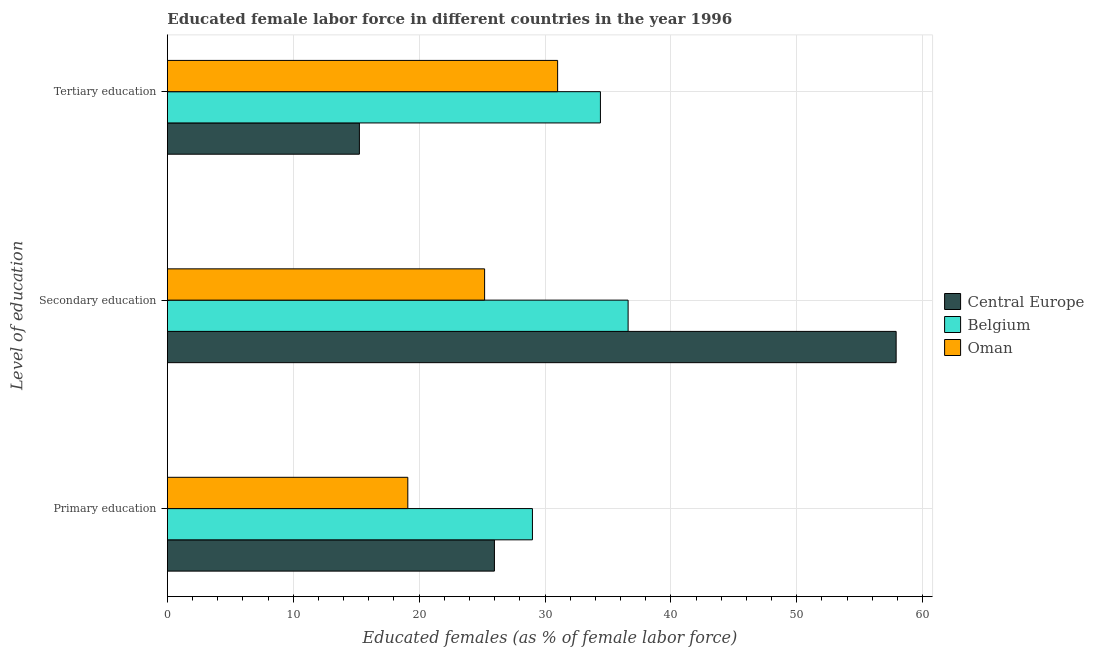How many different coloured bars are there?
Offer a terse response. 3. How many bars are there on the 2nd tick from the bottom?
Your answer should be very brief. 3. What is the label of the 1st group of bars from the top?
Keep it short and to the point. Tertiary education. What is the percentage of female labor force who received tertiary education in Belgium?
Make the answer very short. 34.4. Across all countries, what is the maximum percentage of female labor force who received tertiary education?
Your answer should be very brief. 34.4. Across all countries, what is the minimum percentage of female labor force who received primary education?
Offer a terse response. 19.1. In which country was the percentage of female labor force who received tertiary education minimum?
Your answer should be compact. Central Europe. What is the total percentage of female labor force who received tertiary education in the graph?
Your answer should be very brief. 80.65. What is the difference between the percentage of female labor force who received primary education in Oman and that in Belgium?
Give a very brief answer. -9.9. What is the difference between the percentage of female labor force who received primary education in Central Europe and the percentage of female labor force who received tertiary education in Belgium?
Offer a very short reply. -8.42. What is the average percentage of female labor force who received secondary education per country?
Provide a succinct answer. 39.9. What is the difference between the percentage of female labor force who received tertiary education and percentage of female labor force who received secondary education in Central Europe?
Provide a short and direct response. -42.64. In how many countries, is the percentage of female labor force who received secondary education greater than 52 %?
Your answer should be compact. 1. What is the ratio of the percentage of female labor force who received primary education in Oman to that in Belgium?
Provide a succinct answer. 0.66. Is the percentage of female labor force who received secondary education in Oman less than that in Central Europe?
Give a very brief answer. Yes. Is the difference between the percentage of female labor force who received primary education in Belgium and Central Europe greater than the difference between the percentage of female labor force who received secondary education in Belgium and Central Europe?
Provide a short and direct response. Yes. What is the difference between the highest and the second highest percentage of female labor force who received secondary education?
Make the answer very short. 21.29. What is the difference between the highest and the lowest percentage of female labor force who received tertiary education?
Provide a short and direct response. 19.15. In how many countries, is the percentage of female labor force who received primary education greater than the average percentage of female labor force who received primary education taken over all countries?
Give a very brief answer. 2. What does the 2nd bar from the top in Primary education represents?
Provide a succinct answer. Belgium. What does the 3rd bar from the bottom in Tertiary education represents?
Keep it short and to the point. Oman. How many bars are there?
Give a very brief answer. 9. What is the difference between two consecutive major ticks on the X-axis?
Give a very brief answer. 10. Does the graph contain any zero values?
Provide a succinct answer. No. Does the graph contain grids?
Offer a very short reply. Yes. Where does the legend appear in the graph?
Offer a terse response. Center right. How are the legend labels stacked?
Provide a succinct answer. Vertical. What is the title of the graph?
Provide a short and direct response. Educated female labor force in different countries in the year 1996. What is the label or title of the X-axis?
Offer a terse response. Educated females (as % of female labor force). What is the label or title of the Y-axis?
Offer a very short reply. Level of education. What is the Educated females (as % of female labor force) of Central Europe in Primary education?
Offer a very short reply. 25.98. What is the Educated females (as % of female labor force) of Oman in Primary education?
Your response must be concise. 19.1. What is the Educated females (as % of female labor force) of Central Europe in Secondary education?
Your response must be concise. 57.89. What is the Educated females (as % of female labor force) of Belgium in Secondary education?
Your answer should be very brief. 36.6. What is the Educated females (as % of female labor force) in Oman in Secondary education?
Offer a very short reply. 25.2. What is the Educated females (as % of female labor force) in Central Europe in Tertiary education?
Give a very brief answer. 15.25. What is the Educated females (as % of female labor force) in Belgium in Tertiary education?
Provide a succinct answer. 34.4. What is the Educated females (as % of female labor force) in Oman in Tertiary education?
Offer a very short reply. 31. Across all Level of education, what is the maximum Educated females (as % of female labor force) of Central Europe?
Offer a very short reply. 57.89. Across all Level of education, what is the maximum Educated females (as % of female labor force) in Belgium?
Provide a short and direct response. 36.6. Across all Level of education, what is the maximum Educated females (as % of female labor force) in Oman?
Your answer should be very brief. 31. Across all Level of education, what is the minimum Educated females (as % of female labor force) of Central Europe?
Offer a terse response. 15.25. Across all Level of education, what is the minimum Educated females (as % of female labor force) of Belgium?
Provide a short and direct response. 29. Across all Level of education, what is the minimum Educated females (as % of female labor force) of Oman?
Make the answer very short. 19.1. What is the total Educated females (as % of female labor force) in Central Europe in the graph?
Provide a succinct answer. 99.13. What is the total Educated females (as % of female labor force) of Belgium in the graph?
Provide a succinct answer. 100. What is the total Educated females (as % of female labor force) in Oman in the graph?
Give a very brief answer. 75.3. What is the difference between the Educated females (as % of female labor force) of Central Europe in Primary education and that in Secondary education?
Ensure brevity in your answer.  -31.91. What is the difference between the Educated females (as % of female labor force) of Belgium in Primary education and that in Secondary education?
Make the answer very short. -7.6. What is the difference between the Educated females (as % of female labor force) of Central Europe in Primary education and that in Tertiary education?
Ensure brevity in your answer.  10.73. What is the difference between the Educated females (as % of female labor force) of Belgium in Primary education and that in Tertiary education?
Provide a short and direct response. -5.4. What is the difference between the Educated females (as % of female labor force) of Oman in Primary education and that in Tertiary education?
Provide a short and direct response. -11.9. What is the difference between the Educated females (as % of female labor force) of Central Europe in Secondary education and that in Tertiary education?
Ensure brevity in your answer.  42.64. What is the difference between the Educated females (as % of female labor force) in Central Europe in Primary education and the Educated females (as % of female labor force) in Belgium in Secondary education?
Give a very brief answer. -10.62. What is the difference between the Educated females (as % of female labor force) of Central Europe in Primary education and the Educated females (as % of female labor force) of Oman in Secondary education?
Give a very brief answer. 0.78. What is the difference between the Educated females (as % of female labor force) in Central Europe in Primary education and the Educated females (as % of female labor force) in Belgium in Tertiary education?
Provide a short and direct response. -8.42. What is the difference between the Educated females (as % of female labor force) in Central Europe in Primary education and the Educated females (as % of female labor force) in Oman in Tertiary education?
Give a very brief answer. -5.02. What is the difference between the Educated females (as % of female labor force) of Belgium in Primary education and the Educated females (as % of female labor force) of Oman in Tertiary education?
Keep it short and to the point. -2. What is the difference between the Educated females (as % of female labor force) of Central Europe in Secondary education and the Educated females (as % of female labor force) of Belgium in Tertiary education?
Offer a terse response. 23.49. What is the difference between the Educated females (as % of female labor force) in Central Europe in Secondary education and the Educated females (as % of female labor force) in Oman in Tertiary education?
Offer a very short reply. 26.89. What is the difference between the Educated females (as % of female labor force) in Belgium in Secondary education and the Educated females (as % of female labor force) in Oman in Tertiary education?
Make the answer very short. 5.6. What is the average Educated females (as % of female labor force) of Central Europe per Level of education?
Your response must be concise. 33.04. What is the average Educated females (as % of female labor force) of Belgium per Level of education?
Your answer should be very brief. 33.33. What is the average Educated females (as % of female labor force) in Oman per Level of education?
Provide a short and direct response. 25.1. What is the difference between the Educated females (as % of female labor force) in Central Europe and Educated females (as % of female labor force) in Belgium in Primary education?
Provide a succinct answer. -3.02. What is the difference between the Educated females (as % of female labor force) of Central Europe and Educated females (as % of female labor force) of Oman in Primary education?
Your response must be concise. 6.88. What is the difference between the Educated females (as % of female labor force) of Central Europe and Educated females (as % of female labor force) of Belgium in Secondary education?
Provide a succinct answer. 21.29. What is the difference between the Educated females (as % of female labor force) of Central Europe and Educated females (as % of female labor force) of Oman in Secondary education?
Your answer should be compact. 32.69. What is the difference between the Educated females (as % of female labor force) in Central Europe and Educated females (as % of female labor force) in Belgium in Tertiary education?
Keep it short and to the point. -19.15. What is the difference between the Educated females (as % of female labor force) in Central Europe and Educated females (as % of female labor force) in Oman in Tertiary education?
Offer a terse response. -15.75. What is the ratio of the Educated females (as % of female labor force) of Central Europe in Primary education to that in Secondary education?
Your answer should be compact. 0.45. What is the ratio of the Educated females (as % of female labor force) of Belgium in Primary education to that in Secondary education?
Give a very brief answer. 0.79. What is the ratio of the Educated females (as % of female labor force) in Oman in Primary education to that in Secondary education?
Keep it short and to the point. 0.76. What is the ratio of the Educated females (as % of female labor force) in Central Europe in Primary education to that in Tertiary education?
Offer a terse response. 1.7. What is the ratio of the Educated females (as % of female labor force) in Belgium in Primary education to that in Tertiary education?
Make the answer very short. 0.84. What is the ratio of the Educated females (as % of female labor force) in Oman in Primary education to that in Tertiary education?
Provide a succinct answer. 0.62. What is the ratio of the Educated females (as % of female labor force) of Central Europe in Secondary education to that in Tertiary education?
Offer a terse response. 3.8. What is the ratio of the Educated females (as % of female labor force) in Belgium in Secondary education to that in Tertiary education?
Provide a succinct answer. 1.06. What is the ratio of the Educated females (as % of female labor force) in Oman in Secondary education to that in Tertiary education?
Make the answer very short. 0.81. What is the difference between the highest and the second highest Educated females (as % of female labor force) of Central Europe?
Your answer should be compact. 31.91. What is the difference between the highest and the second highest Educated females (as % of female labor force) in Belgium?
Offer a very short reply. 2.2. What is the difference between the highest and the second highest Educated females (as % of female labor force) of Oman?
Provide a short and direct response. 5.8. What is the difference between the highest and the lowest Educated females (as % of female labor force) in Central Europe?
Offer a terse response. 42.64. What is the difference between the highest and the lowest Educated females (as % of female labor force) of Belgium?
Give a very brief answer. 7.6. What is the difference between the highest and the lowest Educated females (as % of female labor force) in Oman?
Your answer should be compact. 11.9. 